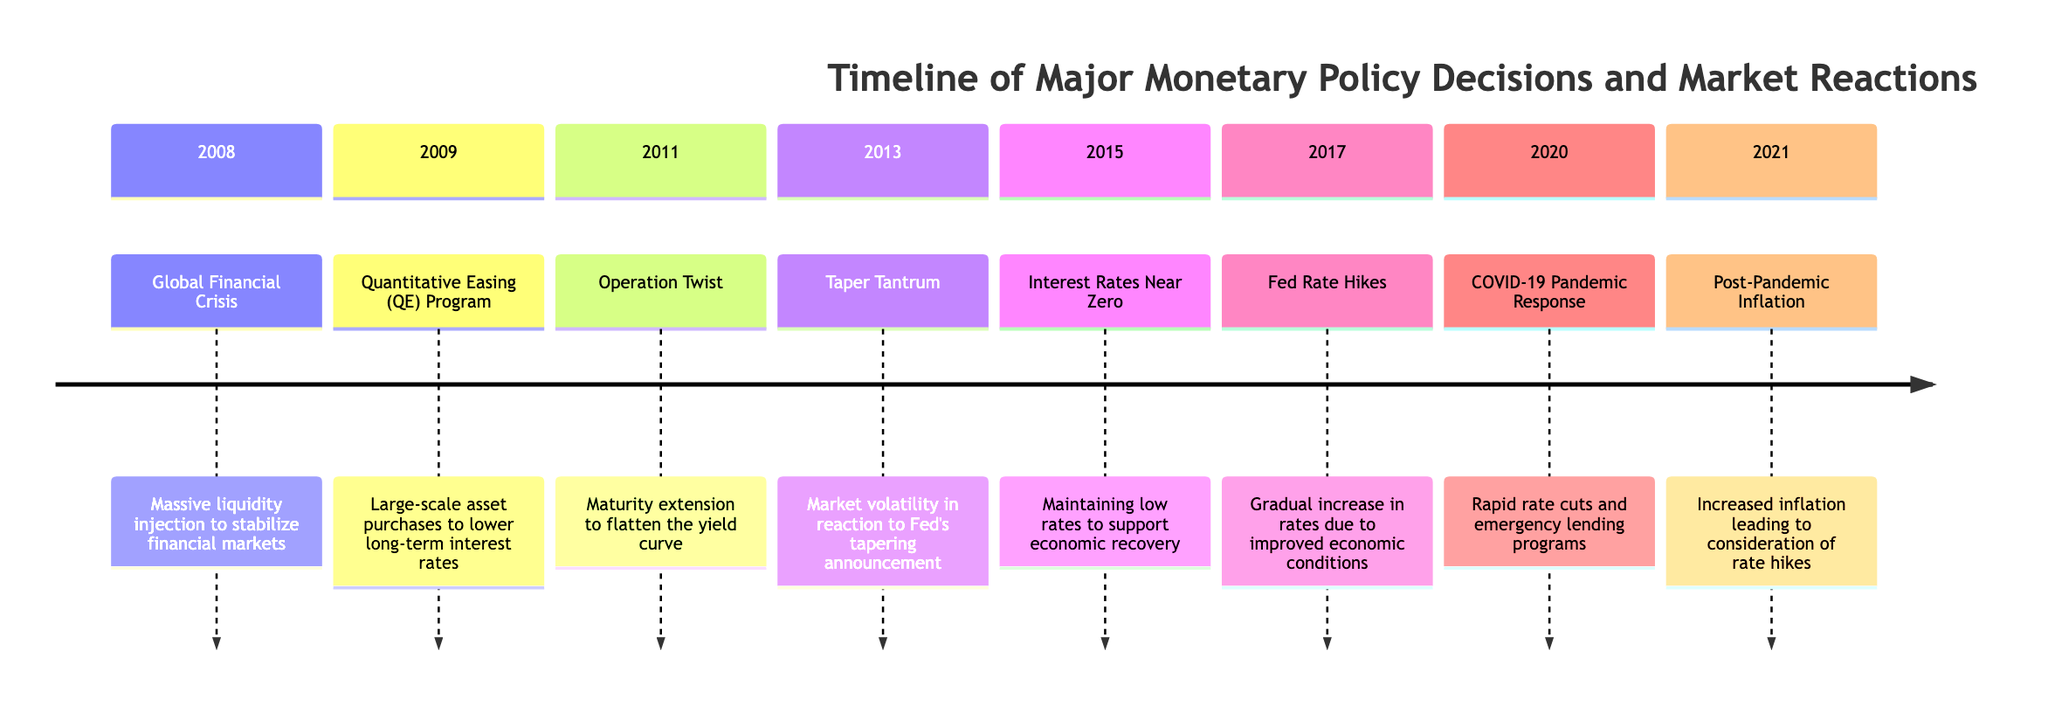What major monetary policy decision occurred in 2008? The diagram indicates that the major monetary policy decision in 2008 was a "Massive liquidity injection to stabilize financial markets." This is a specific event listed under the 2008 section of the timeline.
Answer: Massive liquidity injection What was the purpose of the Quantitative Easing program initiated in 2009? The diagram states that the purpose of the Quantitative Easing (QE) Program in 2009 was "Large-scale asset purchases to lower long-term interest rates." This describes the rationale for implementing this monetary policy.
Answer: Lower long-term interest rates How many major monetary policy decisions are outlined in the diagram? By counting each section in the timeline, we find that there are eight distinct policy decisions, as evidenced by the sections spanning from 2008 to 2021.
Answer: Eight Which year introduced Operation Twist? Looking at the timeline, it shows that Operation Twist was introduced in 2011. This is clearly marked and provides a date for the corresponding monetary policy decision.
Answer: 2011 What market reaction did the Taper Tantrum in 2013 cause? The diagram indicates that the Taper Tantrum in 2013 resulted in "Market volatility in reaction to Fed's tapering announcement." This reflects the direct outcomes of this specific event on the market.
Answer: Market volatility In what year did the Fed begin gradual rate hikes? The timeline explicitly states that the Federal Reserve began gradual rate hikes in 2017. This is clearly indicated in the section detailing that year's monetary policy decision.
Answer: 2017 Why were interest rates kept near zero in 2015? According to the diagram, interest rates were kept near zero in 2015 to "support economic recovery." This is the rationale provided for maintaining low rates during this period.
Answer: Support economic recovery What was the primary monetary response to the COVID-19 pandemic in 2020? The timeline reveals that the primary response to the COVID-19 pandemic in 2020 was "Rapid rate cuts and emergency lending programs." This encapsulates the key actions taken during that time.
Answer: Rapid rate cuts and emergency lending programs What was the key concern in 2021 following the pandemic? The diagram states that in 2021, the key concern was "Increased inflation leading to consideration of rate hikes." This reflects the monetary policy challenges faced in that year.
Answer: Increased inflation leading to consideration of rate hikes 